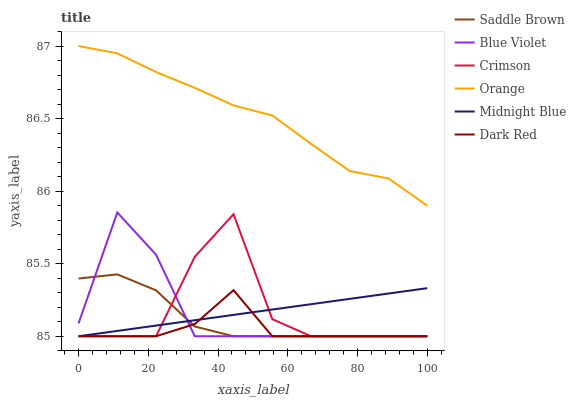Does Dark Red have the minimum area under the curve?
Answer yes or no. Yes. Does Orange have the maximum area under the curve?
Answer yes or no. Yes. Does Orange have the minimum area under the curve?
Answer yes or no. No. Does Dark Red have the maximum area under the curve?
Answer yes or no. No. Is Midnight Blue the smoothest?
Answer yes or no. Yes. Is Crimson the roughest?
Answer yes or no. Yes. Is Dark Red the smoothest?
Answer yes or no. No. Is Dark Red the roughest?
Answer yes or no. No. Does Midnight Blue have the lowest value?
Answer yes or no. Yes. Does Orange have the lowest value?
Answer yes or no. No. Does Orange have the highest value?
Answer yes or no. Yes. Does Dark Red have the highest value?
Answer yes or no. No. Is Dark Red less than Orange?
Answer yes or no. Yes. Is Orange greater than Dark Red?
Answer yes or no. Yes. Does Dark Red intersect Saddle Brown?
Answer yes or no. Yes. Is Dark Red less than Saddle Brown?
Answer yes or no. No. Is Dark Red greater than Saddle Brown?
Answer yes or no. No. Does Dark Red intersect Orange?
Answer yes or no. No. 